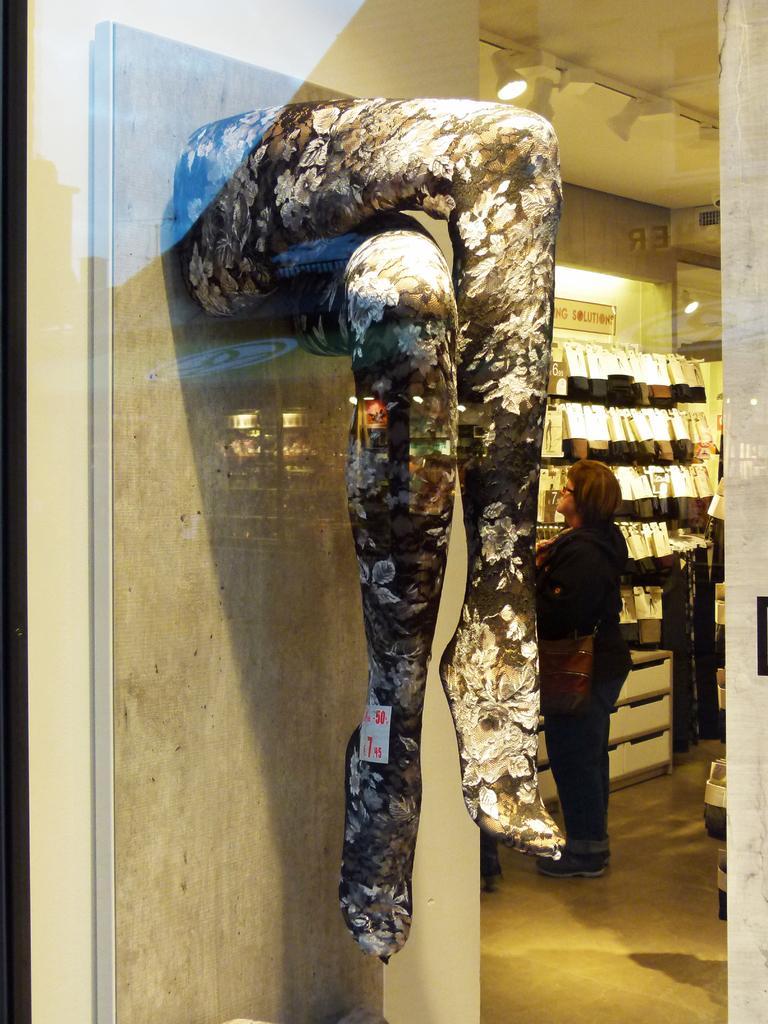Could you give a brief overview of what you see in this image? This picture is clicked inside. On the left we can see the sculpture of the legs of a person which is attached to the wall and we can see a person standing on the ground and there are some objects hanging on the wall. At the top there is a roof and the lights. 